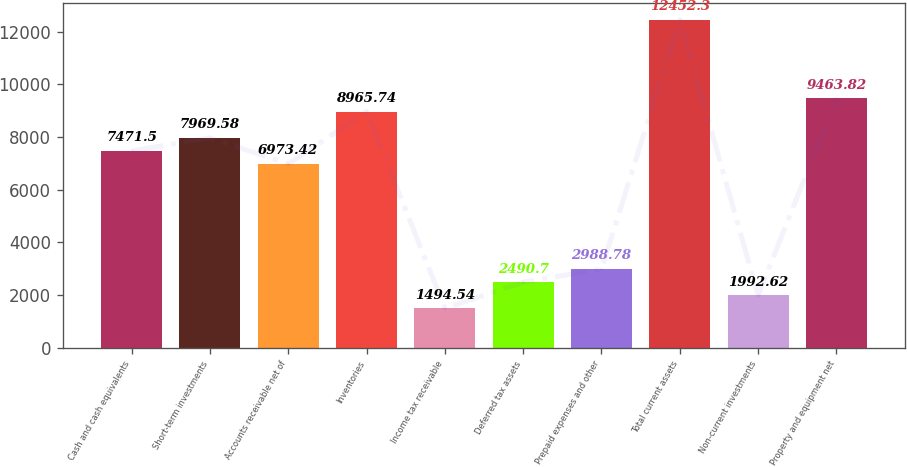<chart> <loc_0><loc_0><loc_500><loc_500><bar_chart><fcel>Cash and cash equivalents<fcel>Short-term investments<fcel>Accounts receivable net of<fcel>Inventories<fcel>Income tax receivable<fcel>Deferred tax assets<fcel>Prepaid expenses and other<fcel>Total current assets<fcel>Non-current investments<fcel>Property and equipment net<nl><fcel>7471.5<fcel>7969.58<fcel>6973.42<fcel>8965.74<fcel>1494.54<fcel>2490.7<fcel>2988.78<fcel>12452.3<fcel>1992.62<fcel>9463.82<nl></chart> 